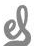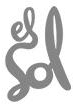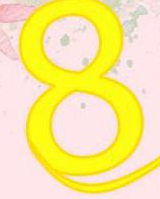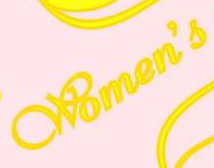Transcribe the words shown in these images in order, separated by a semicolon. el; Sol; 8; Women's 